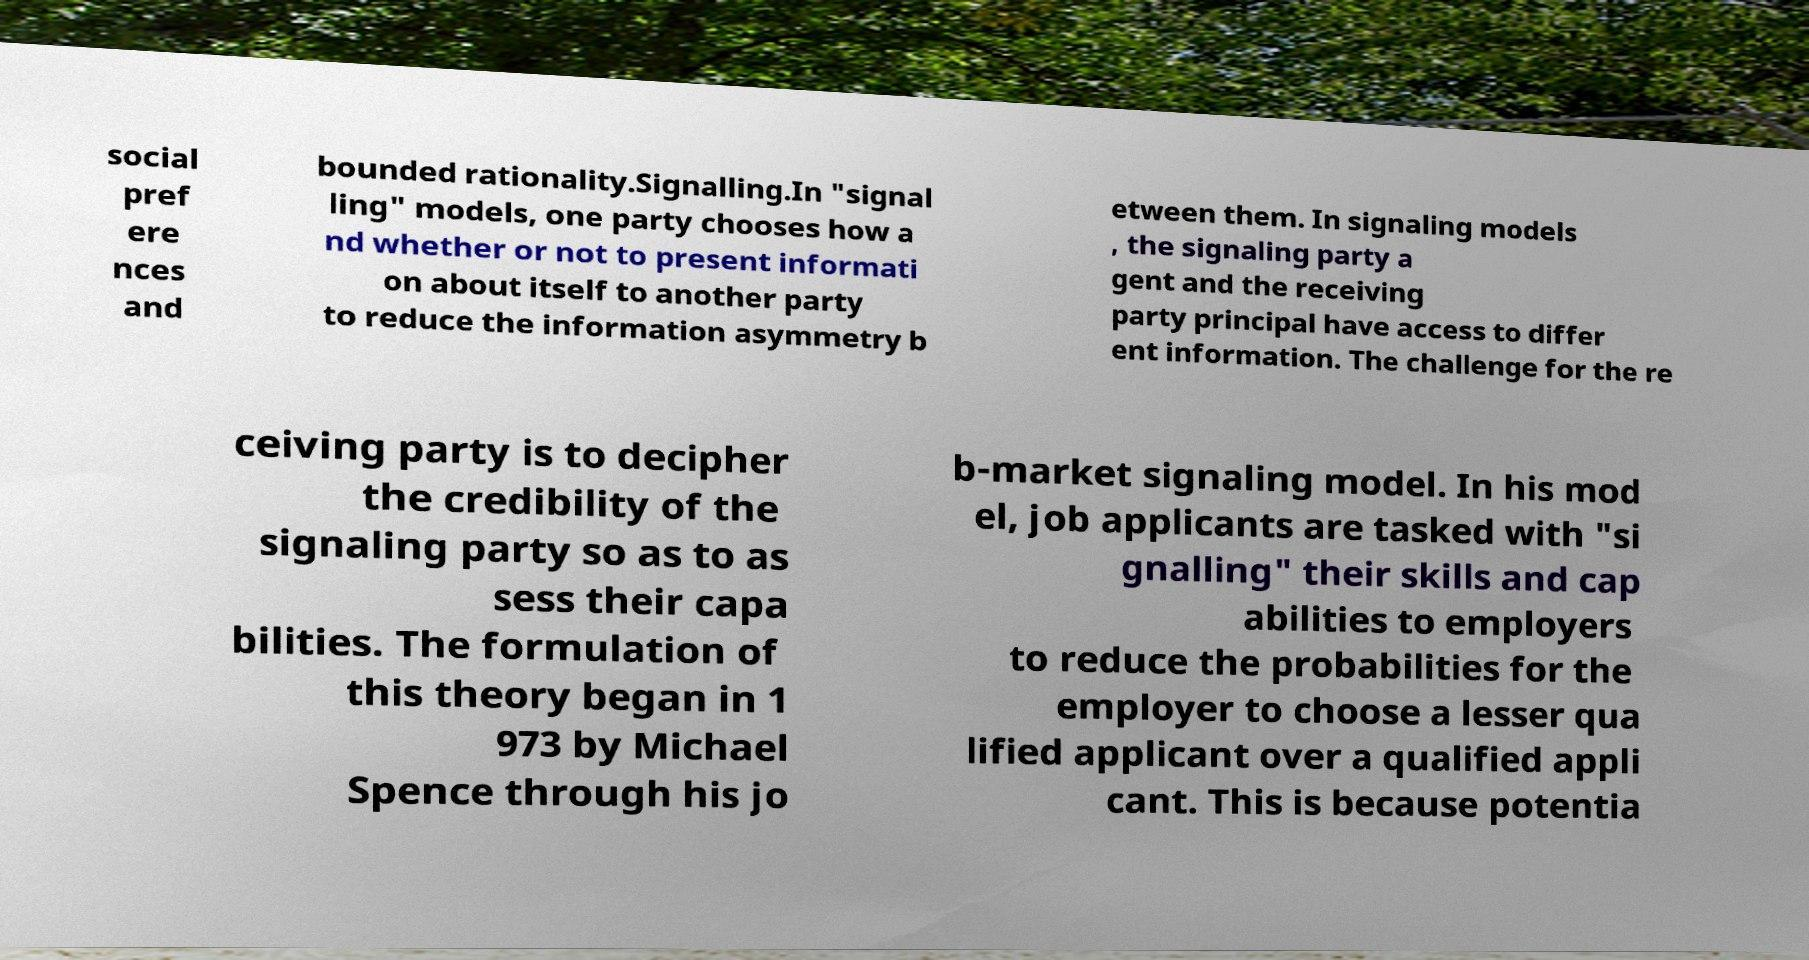What messages or text are displayed in this image? I need them in a readable, typed format. social pref ere nces and bounded rationality.Signalling.In "signal ling" models, one party chooses how a nd whether or not to present informati on about itself to another party to reduce the information asymmetry b etween them. In signaling models , the signaling party a gent and the receiving party principal have access to differ ent information. The challenge for the re ceiving party is to decipher the credibility of the signaling party so as to as sess their capa bilities. The formulation of this theory began in 1 973 by Michael Spence through his jo b-market signaling model. In his mod el, job applicants are tasked with "si gnalling" their skills and cap abilities to employers to reduce the probabilities for the employer to choose a lesser qua lified applicant over a qualified appli cant. This is because potentia 